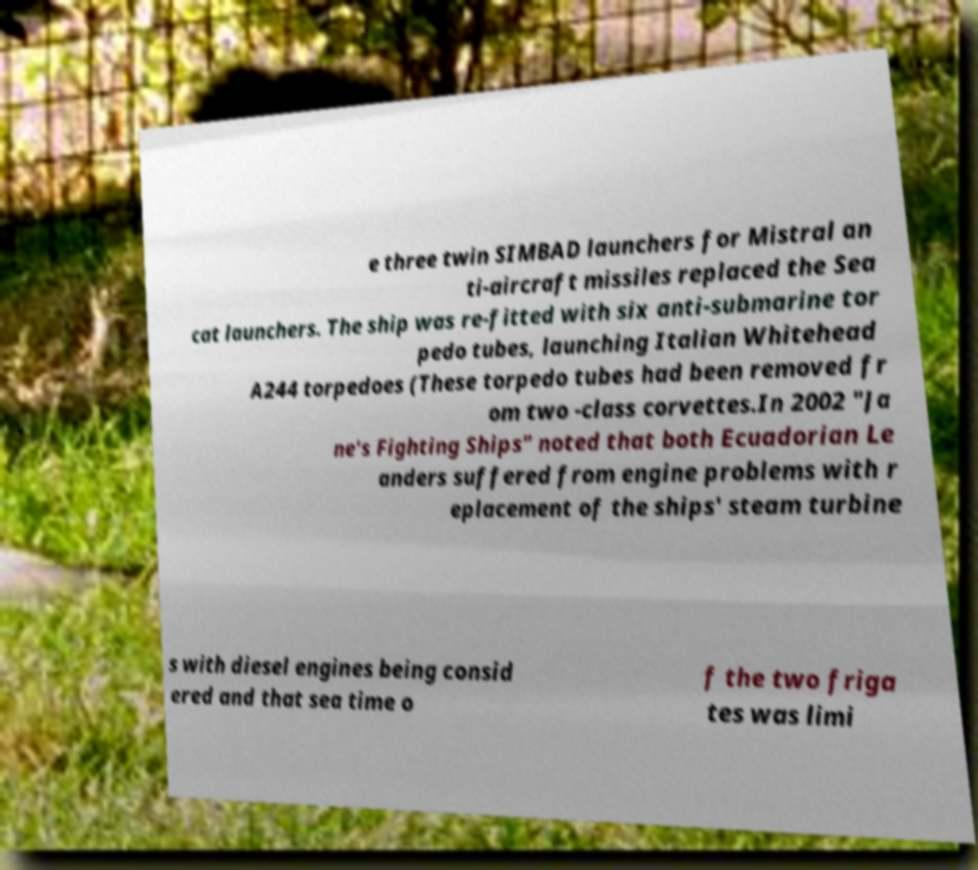Please read and relay the text visible in this image. What does it say? e three twin SIMBAD launchers for Mistral an ti-aircraft missiles replaced the Sea cat launchers. The ship was re-fitted with six anti-submarine tor pedo tubes, launching Italian Whitehead A244 torpedoes (These torpedo tubes had been removed fr om two -class corvettes.In 2002 "Ja ne's Fighting Ships" noted that both Ecuadorian Le anders suffered from engine problems with r eplacement of the ships' steam turbine s with diesel engines being consid ered and that sea time o f the two friga tes was limi 